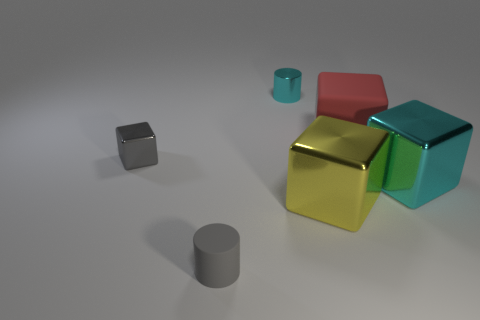What size is the red rubber object?
Offer a terse response. Large. What number of other things are the same color as the matte block?
Your response must be concise. 0. There is a cyan object that is in front of the gray metallic block; does it have the same shape as the red object?
Provide a short and direct response. Yes. There is a large matte thing that is the same shape as the small gray metallic object; what color is it?
Offer a very short reply. Red. The yellow object that is the same shape as the red rubber thing is what size?
Give a very brief answer. Large. The big object that is in front of the red object and behind the yellow cube is made of what material?
Give a very brief answer. Metal. Is the color of the metallic object on the left side of the gray rubber thing the same as the small matte object?
Give a very brief answer. Yes. There is a rubber cylinder; is its color the same as the shiny cube behind the big cyan metal thing?
Your answer should be very brief. Yes. Are there any big objects right of the big red cube?
Your answer should be compact. Yes. Is the large yellow cube made of the same material as the gray cylinder?
Provide a succinct answer. No. 